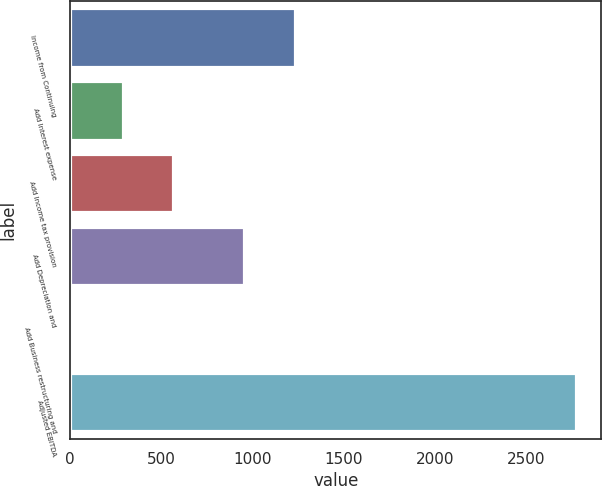<chart> <loc_0><loc_0><loc_500><loc_500><bar_chart><fcel>Income from Continuing<fcel>Add Interest expense<fcel>Add Income tax provision<fcel>Add Depreciation and<fcel>Add Business restructuring and<fcel>Adjusted EBITDA<nl><fcel>1233.2<fcel>289<fcel>565.3<fcel>956.9<fcel>12.7<fcel>2775.7<nl></chart> 